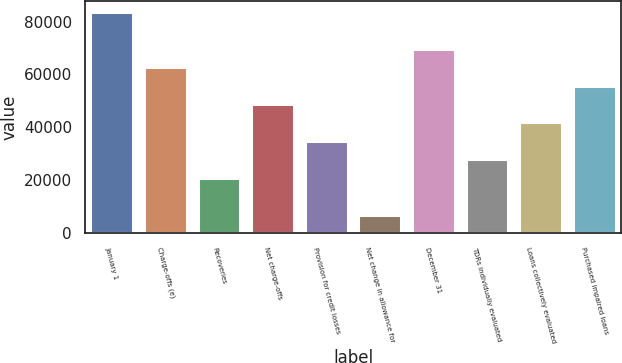Convert chart. <chart><loc_0><loc_0><loc_500><loc_500><bar_chart><fcel>January 1<fcel>Charge-offs (e)<fcel>Recoveries<fcel>Net charge-offs<fcel>Provision for credit losses<fcel>Net change in allowance for<fcel>December 31<fcel>TDRs individually evaluated<fcel>Loans collectively evaluated<fcel>Purchased impaired loans<nl><fcel>83668.3<fcel>62751.9<fcel>20919<fcel>48807.6<fcel>34863.3<fcel>6974.77<fcel>69724<fcel>27891.2<fcel>41835.5<fcel>55779.8<nl></chart> 